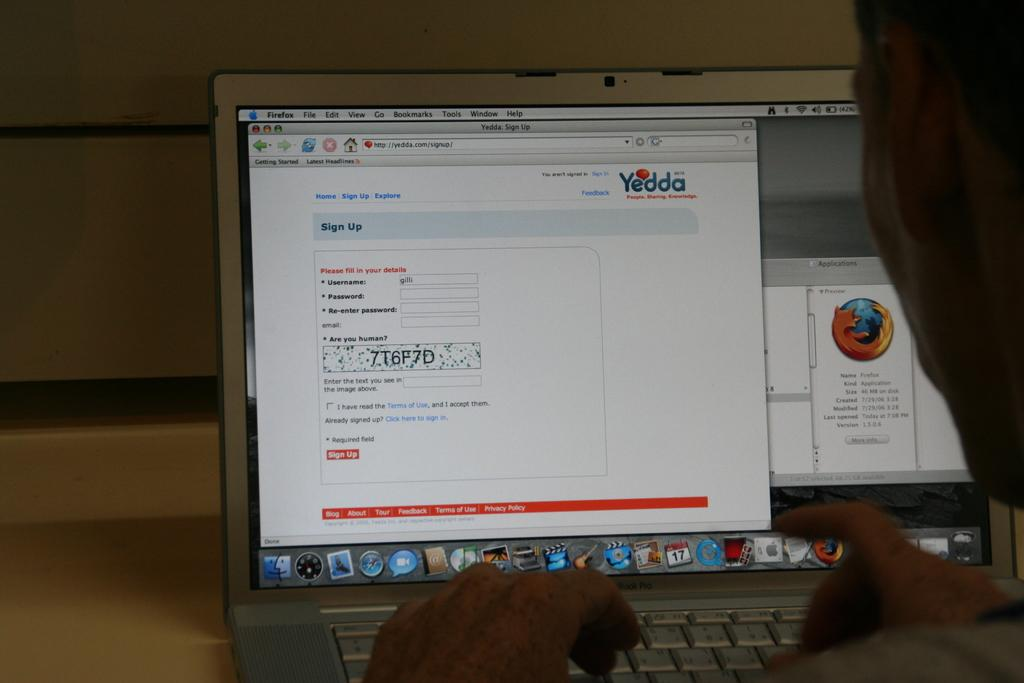<image>
Present a compact description of the photo's key features. A computer screen with the word Yedda in the top right corner 